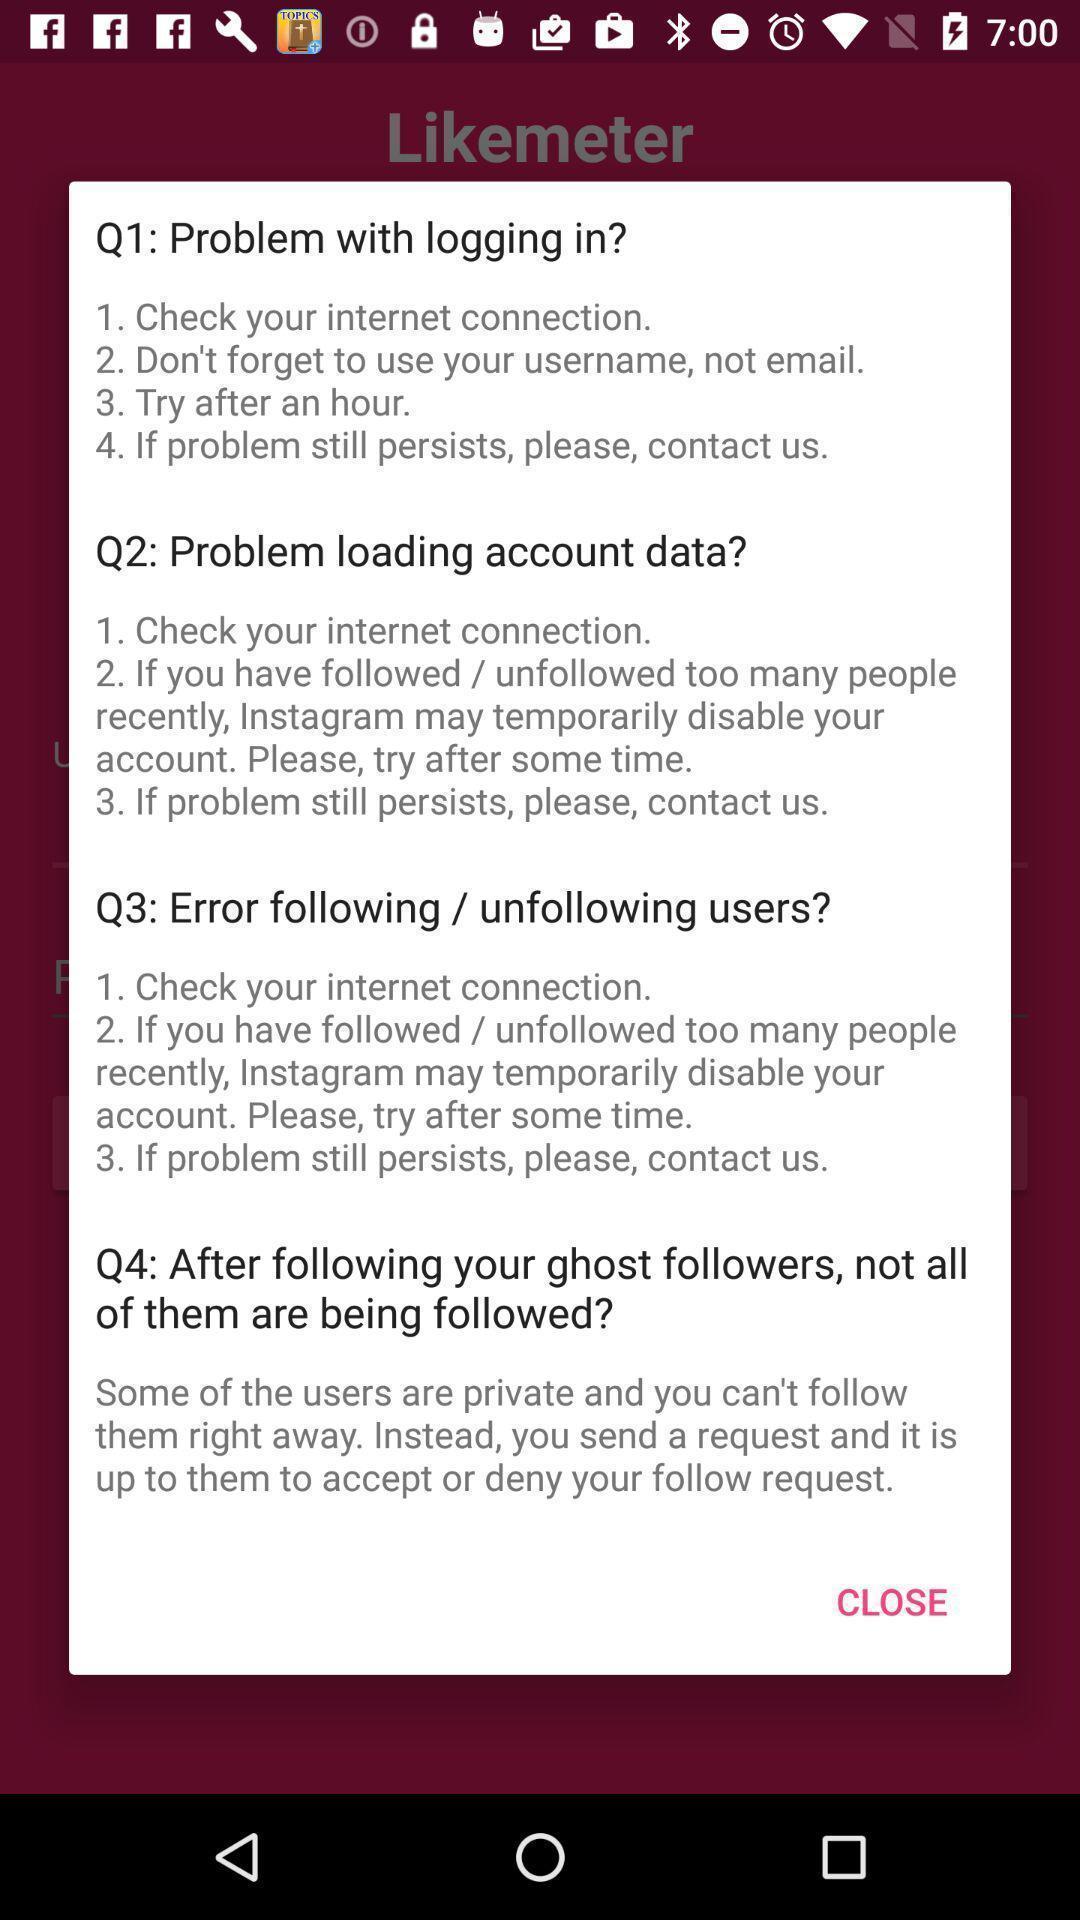Describe the key features of this screenshot. Pop-up displaying information about an application. 